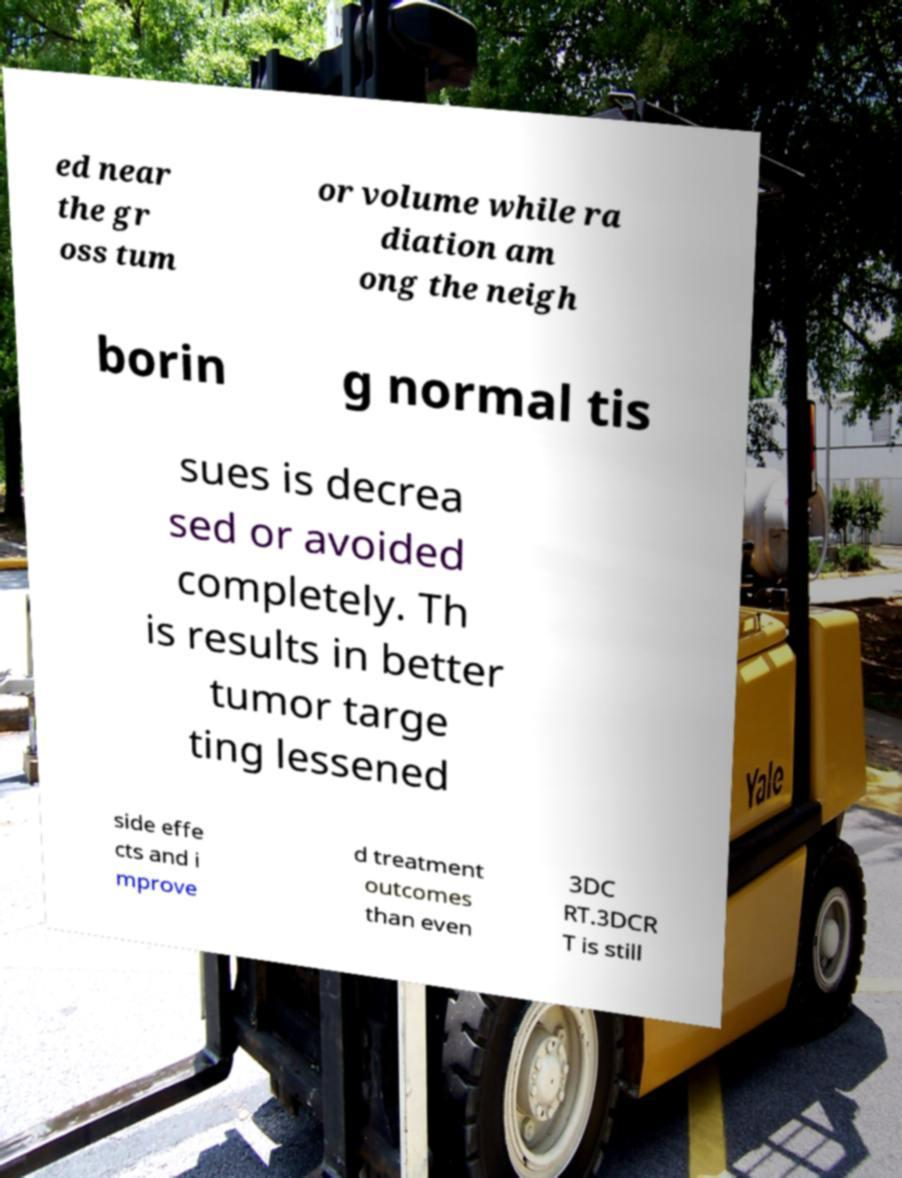There's text embedded in this image that I need extracted. Can you transcribe it verbatim? ed near the gr oss tum or volume while ra diation am ong the neigh borin g normal tis sues is decrea sed or avoided completely. Th is results in better tumor targe ting lessened side effe cts and i mprove d treatment outcomes than even 3DC RT.3DCR T is still 